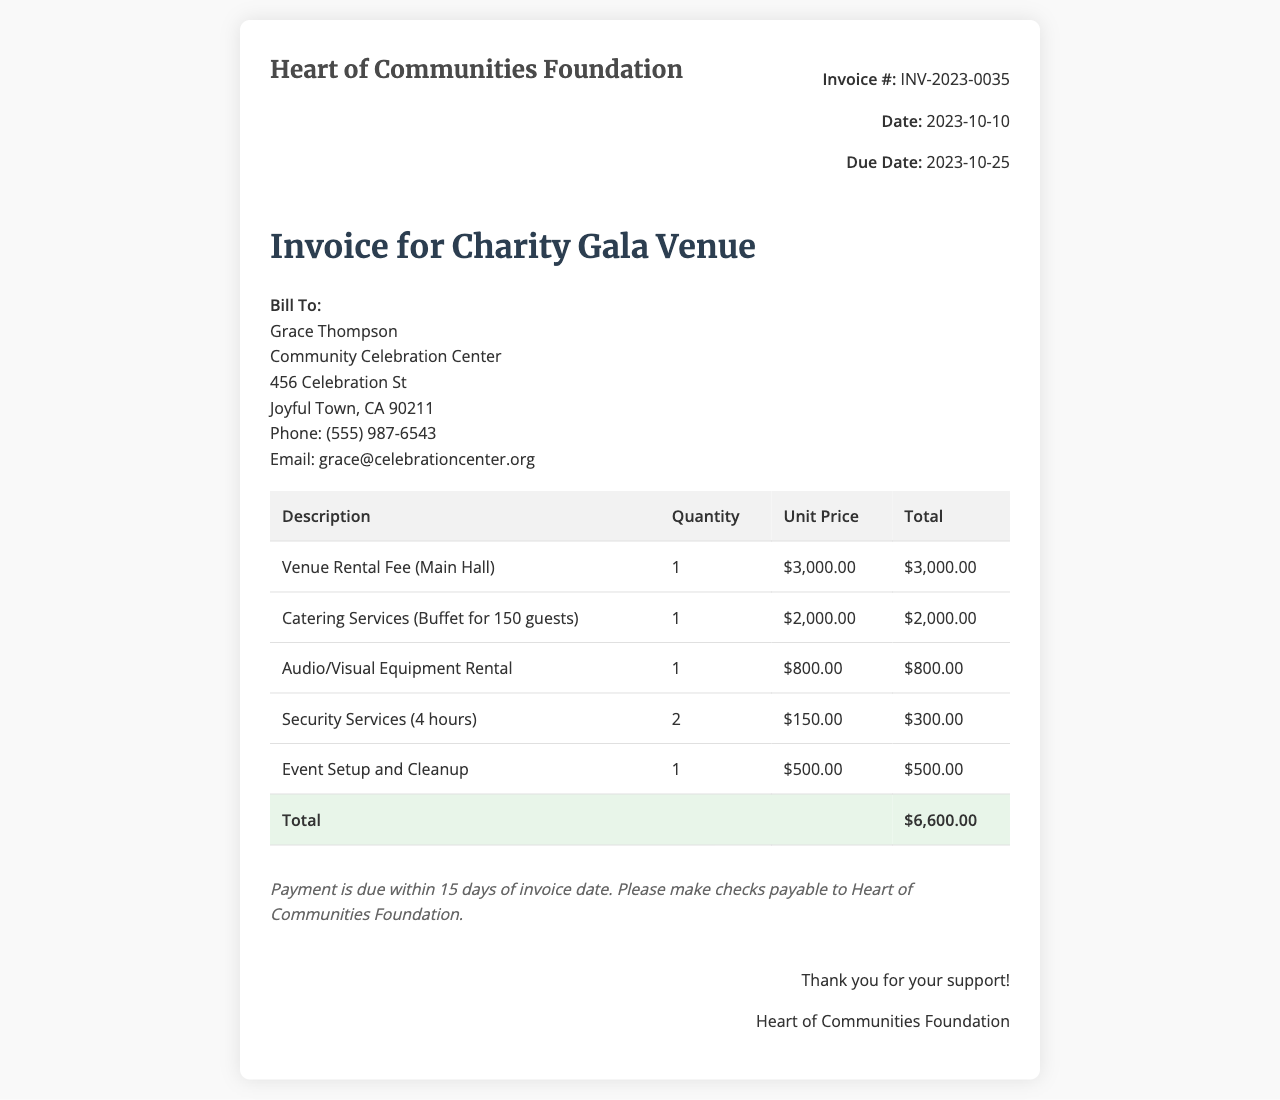What is the invoice number? The invoice number is identified in the details section, noted as INV-2023-0035.
Answer: INV-2023-0035 What is the total amount due? The total amount due is found in the total row of the invoice, which is $6,600.00.
Answer: $6,600.00 Who is the invoice billed to? The billing section identifies the recipient, which is Grace Thompson.
Answer: Grace Thompson What is the date of the invoice? The date is indicated in the invoice details, marked as 2023-10-10.
Answer: 2023-10-10 How much is the venue rental fee? The venue rental fee is detailed in the table, listed as $3,000.00.
Answer: $3,000.00 How many guests were catered for? The catering services specify that it is for 150 guests, as mentioned in the description.
Answer: 150 guests What is the payment term for this invoice? The payment term is described in the terms section, stating that payment is due within 15 days of the invoice date.
Answer: 15 days Which service had the highest cost? The breakdown of services shows that the venue rental fee had the highest cost at $3,000.00.
Answer: Venue Rental Fee How many hours of security services were billed? The invoice lists security services for a total of 4 hours specified under that service description.
Answer: 4 hours 